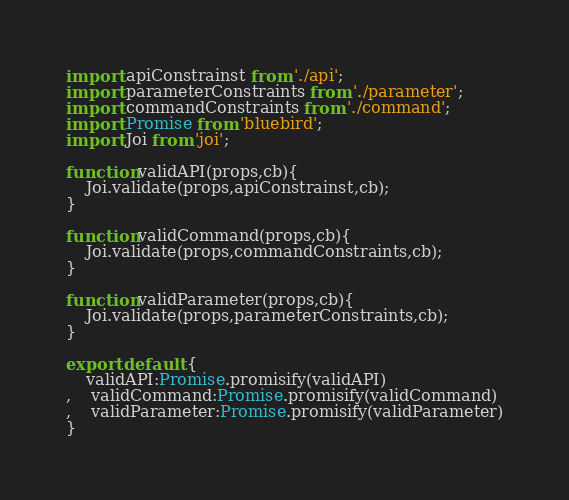<code> <loc_0><loc_0><loc_500><loc_500><_JavaScript_>import apiConstrainst from './api';
import parameterConstraints from './parameter';
import commandConstraints from './command';
import Promise from 'bluebird';
import Joi from 'joi';

function validAPI(props,cb){
	Joi.validate(props,apiConstrainst,cb);
}

function validCommand(props,cb){
	Joi.validate(props,commandConstraints,cb);
}

function validParameter(props,cb){
	Joi.validate(props,parameterConstraints,cb);
}

export default {
	validAPI:Promise.promisify(validAPI)
,	validCommand:Promise.promisify(validCommand)
,	validParameter:Promise.promisify(validParameter)
}</code> 